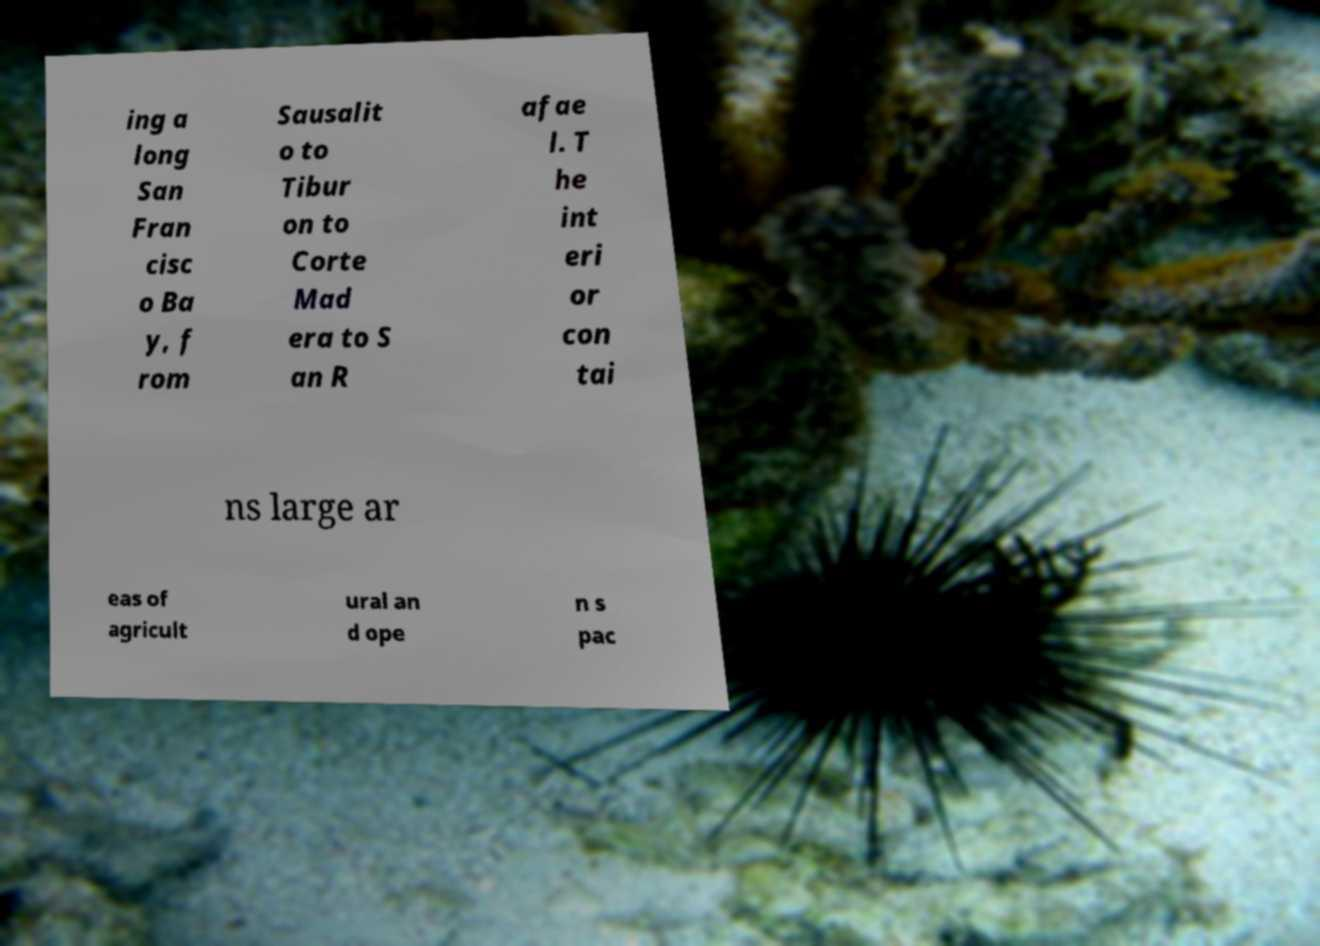Please identify and transcribe the text found in this image. ing a long San Fran cisc o Ba y, f rom Sausalit o to Tibur on to Corte Mad era to S an R afae l. T he int eri or con tai ns large ar eas of agricult ural an d ope n s pac 